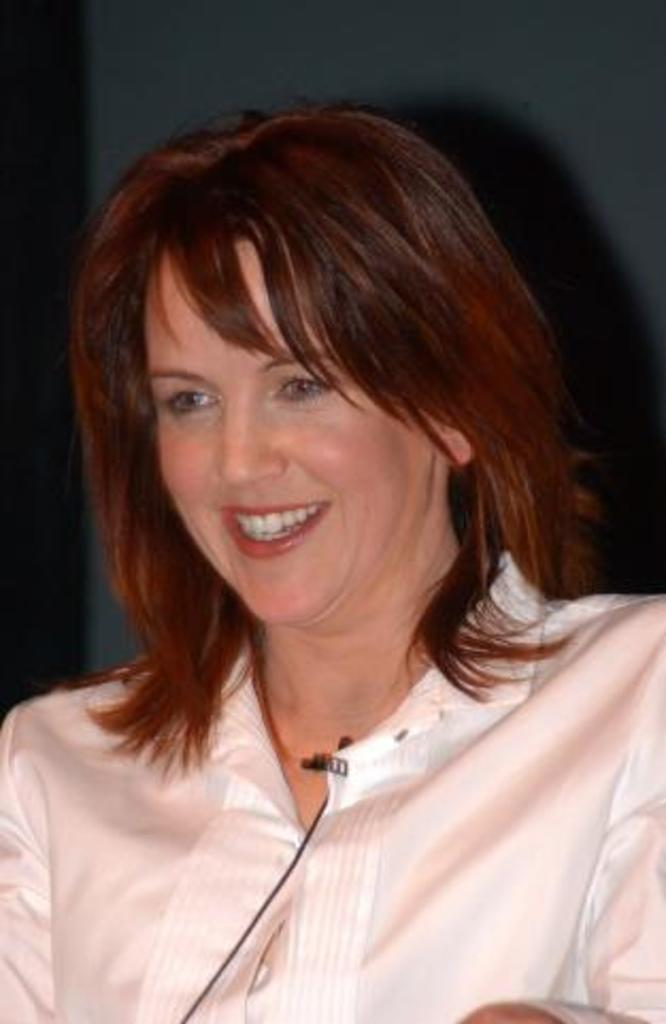Who is the main subject in the foreground of the image? There is a woman in the foreground of the image. What is the woman wearing in the image? The woman is wearing a white shirt. What is the woman's facial expression in the image? The woman is smiling. What can be seen in the background of the image? There is a wall in the background of the image. What type of disease is the woman suffering from in the image? There is no indication in the image that the woman is suffering from any disease. What type of guitar is the woman playing in the image? There is no guitar present in the image; the woman is simply smiling. 